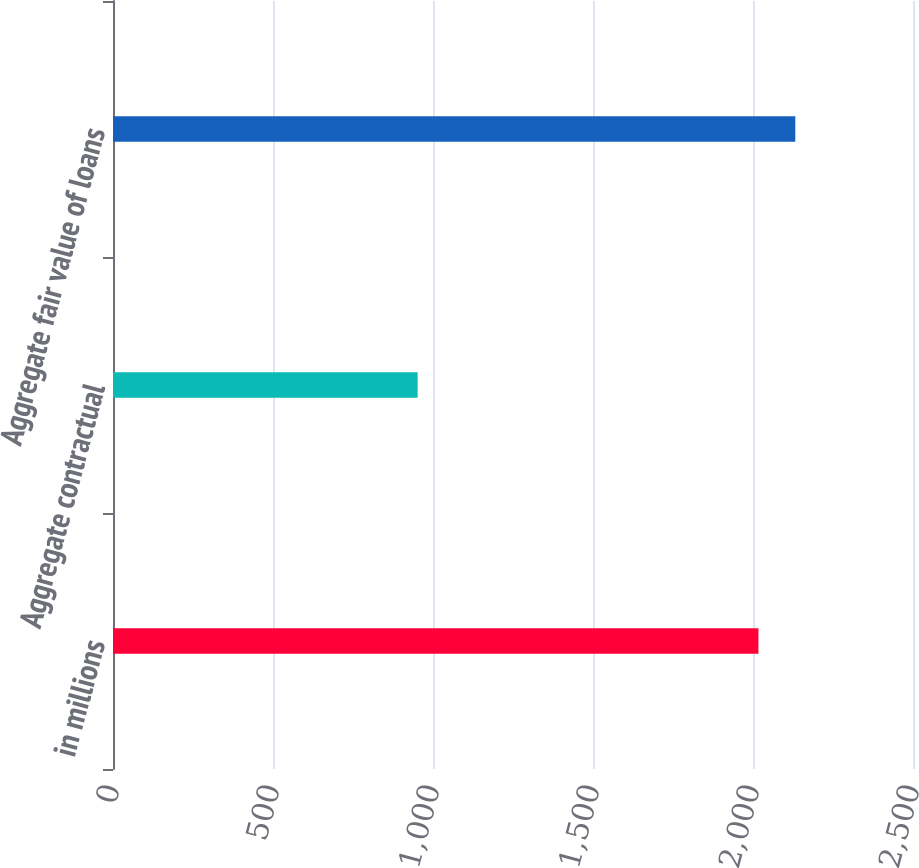Convert chart. <chart><loc_0><loc_0><loc_500><loc_500><bar_chart><fcel>in millions<fcel>Aggregate contractual<fcel>Aggregate fair value of loans<nl><fcel>2017<fcel>952<fcel>2132.2<nl></chart> 